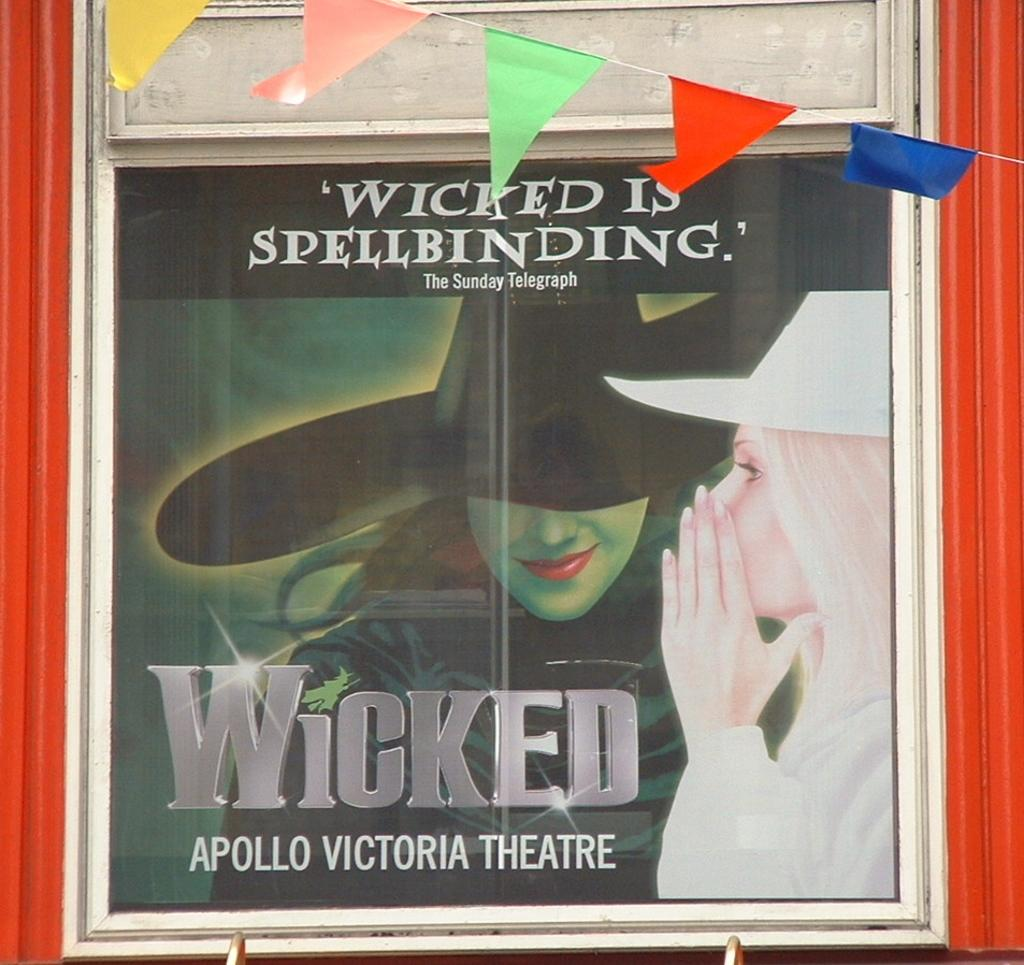Provide a one-sentence caption for the provided image. an ad for the play Wicked at the Apollo Victoria Theater. 